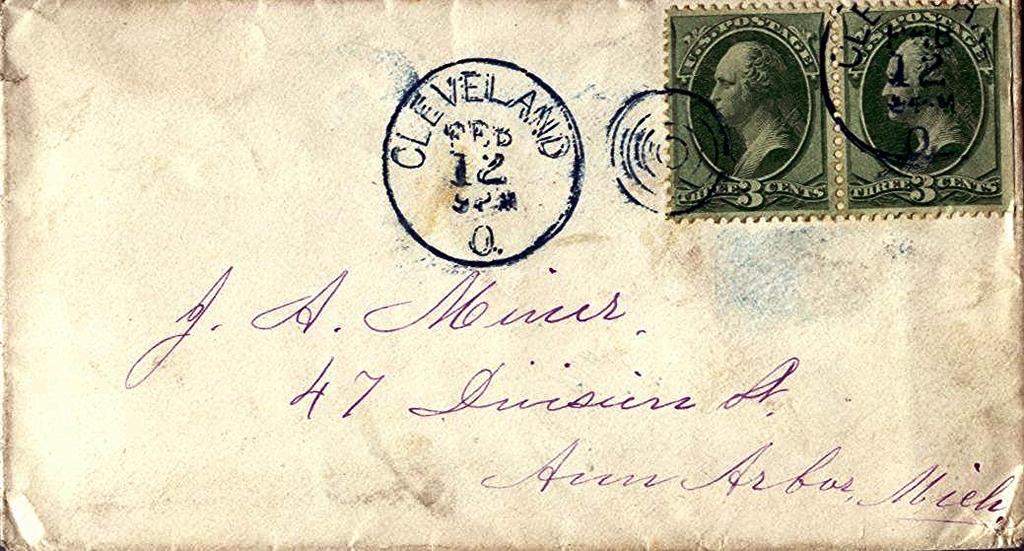What city is the stamp from?
Make the answer very short. Cleveland. Who is letter being sent to?
Your answer should be very brief. Unanswerable. 